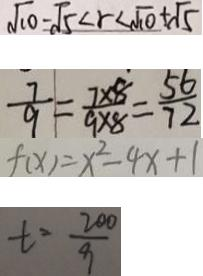<formula> <loc_0><loc_0><loc_500><loc_500>\sqrt { 1 0 } - \sqrt { 5 } < r < \sqrt { 1 0 } + \sqrt { 5 } 
 \frac { 7 } { 9 } = \frac { 7 \times 8 } { 9 \times 8 } = \frac { 5 6 } { 7 2 } 
 f ( x ) = x ^ { 2 } - 4 x + 1 
 t = \frac { 2 0 0 } { 9 }</formula> 